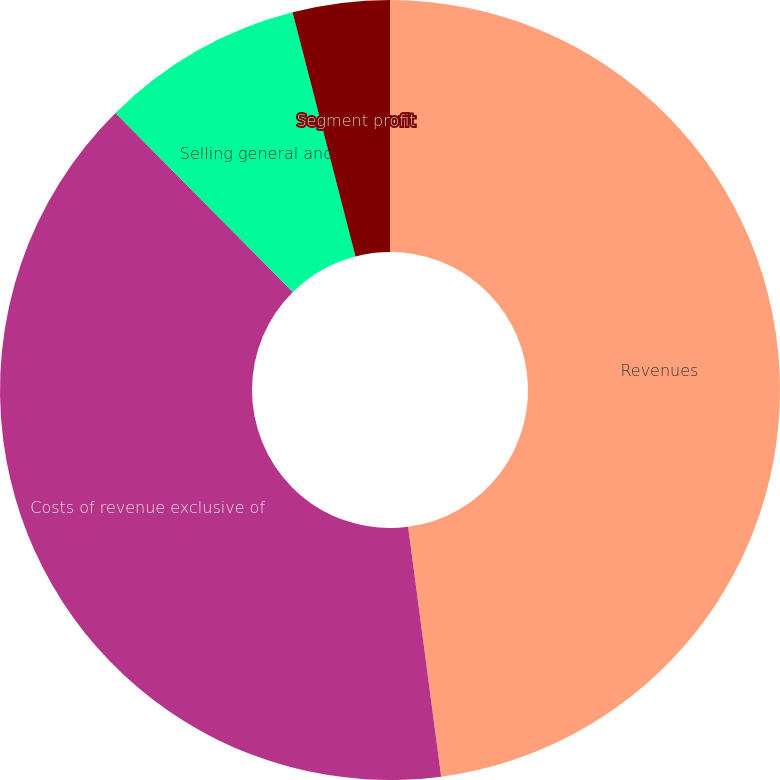Convert chart. <chart><loc_0><loc_0><loc_500><loc_500><pie_chart><fcel>Revenues<fcel>Costs of revenue exclusive of<fcel>Selling general and<fcel>Segment profit<nl><fcel>47.91%<fcel>39.67%<fcel>8.41%<fcel>4.02%<nl></chart> 